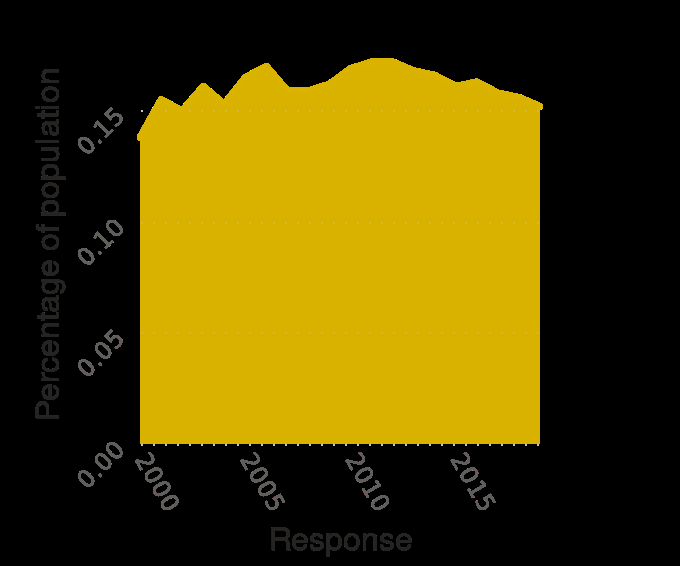<image>
Was there any significant increase in poverty in Oklahoma between 2010 and 2019? The description does not mention any significant increase in poverty in Oklahoma between 2010 and 2019. What does the y-axis represent? The y-axis represents the percentage of the population, ranging from 0.00 to 0.15. please summary the statistics and relations of the chart The percentage of the population in poverty in Oklahoma stays roughly the same between 2000 and 2019. There was a decrease in the poverty rate in Oklahoma between 2010 and 2019. 